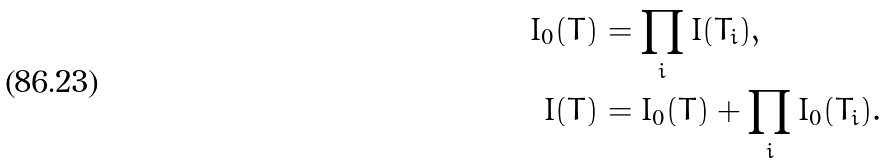<formula> <loc_0><loc_0><loc_500><loc_500>I _ { 0 } ( T ) & = \prod _ { i } I ( T _ { i } ) , \\ I ( T ) & = I _ { 0 } ( T ) + \prod _ { i } I _ { 0 } ( T _ { i } ) .</formula> 